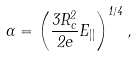Convert formula to latex. <formula><loc_0><loc_0><loc_500><loc_500>\Gamma = \left ( \frac { 3 R _ { c } ^ { 2 } } { 2 e } E _ { | | } \right ) ^ { 1 / 4 } ,</formula> 